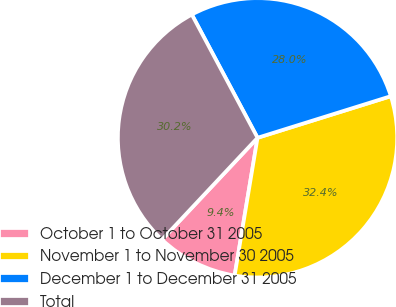Convert chart to OTSL. <chart><loc_0><loc_0><loc_500><loc_500><pie_chart><fcel>October 1 to October 31 2005<fcel>November 1 to November 30 2005<fcel>December 1 to December 31 2005<fcel>Total<nl><fcel>9.37%<fcel>32.44%<fcel>27.98%<fcel>30.21%<nl></chart> 